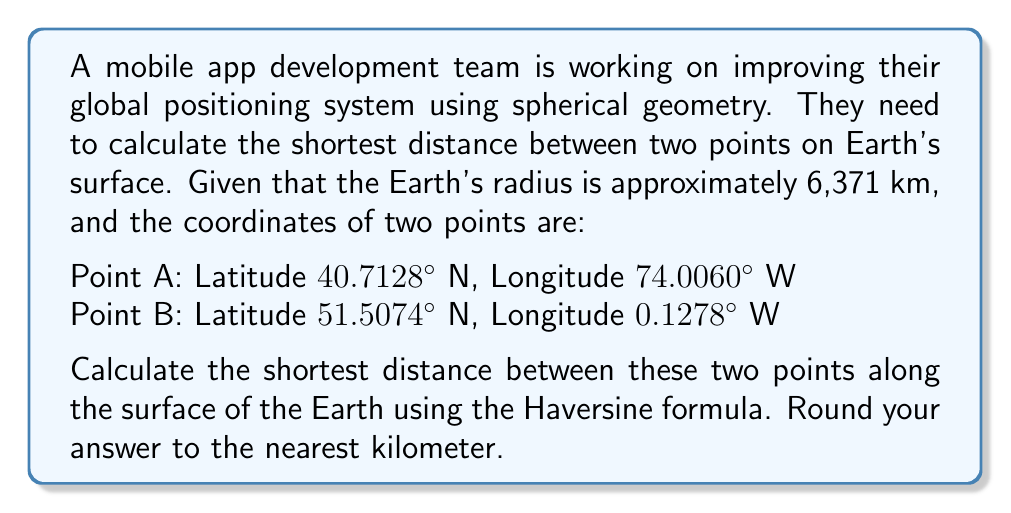Could you help me with this problem? To solve this problem, we'll use the Haversine formula, which is ideal for calculating great-circle distances on a sphere. Here's the step-by-step solution:

1. Convert the latitudes and longitudes from degrees to radians:
   $\phi_1 = 40.7128° \times \frac{\pi}{180} = 0.7102$ rad
   $\lambda_1 = -74.0060° \times \frac{\pi}{180} = -1.2915$ rad
   $\phi_2 = 51.5074° \times \frac{\pi}{180} = 0.8989$ rad
   $\lambda_2 = -0.1278° \times \frac{\pi}{180} = -0.0022$ rad

2. Calculate the differences in latitude and longitude:
   $\Delta\phi = \phi_2 - \phi_1 = 0.1887$ rad
   $\Delta\lambda = \lambda_2 - \lambda_1 = 1.2893$ rad

3. Apply the Haversine formula:
   $$a = \sin^2(\frac{\Delta\phi}{2}) + \cos(\phi_1) \cos(\phi_2) \sin^2(\frac{\Delta\lambda}{2})$$
   $$c = 2 \times \arctan2(\sqrt{a}, \sqrt{1-a})$$
   $$d = R \times c$$

   Where $R$ is the Earth's radius (6,371 km)

4. Calculate $a$:
   $$a = \sin^2(0.0944) + \cos(0.7102) \cos(0.8989) \sin^2(0.6447)$$
   $$a = 0.0089 + 0.7660 \times 0.7792 \times 0.3437 = 0.2088$$

5. Calculate $c$:
   $$c = 2 \times \arctan2(\sqrt{0.2088}, \sqrt{1-0.2088}) = 0.9474$$

6. Calculate the distance $d$:
   $$d = 6371 \times 0.9474 = 6035.78 \text{ km}$$

7. Round to the nearest kilometer:
   $d \approx 6036 \text{ km}$
Answer: 6036 km 